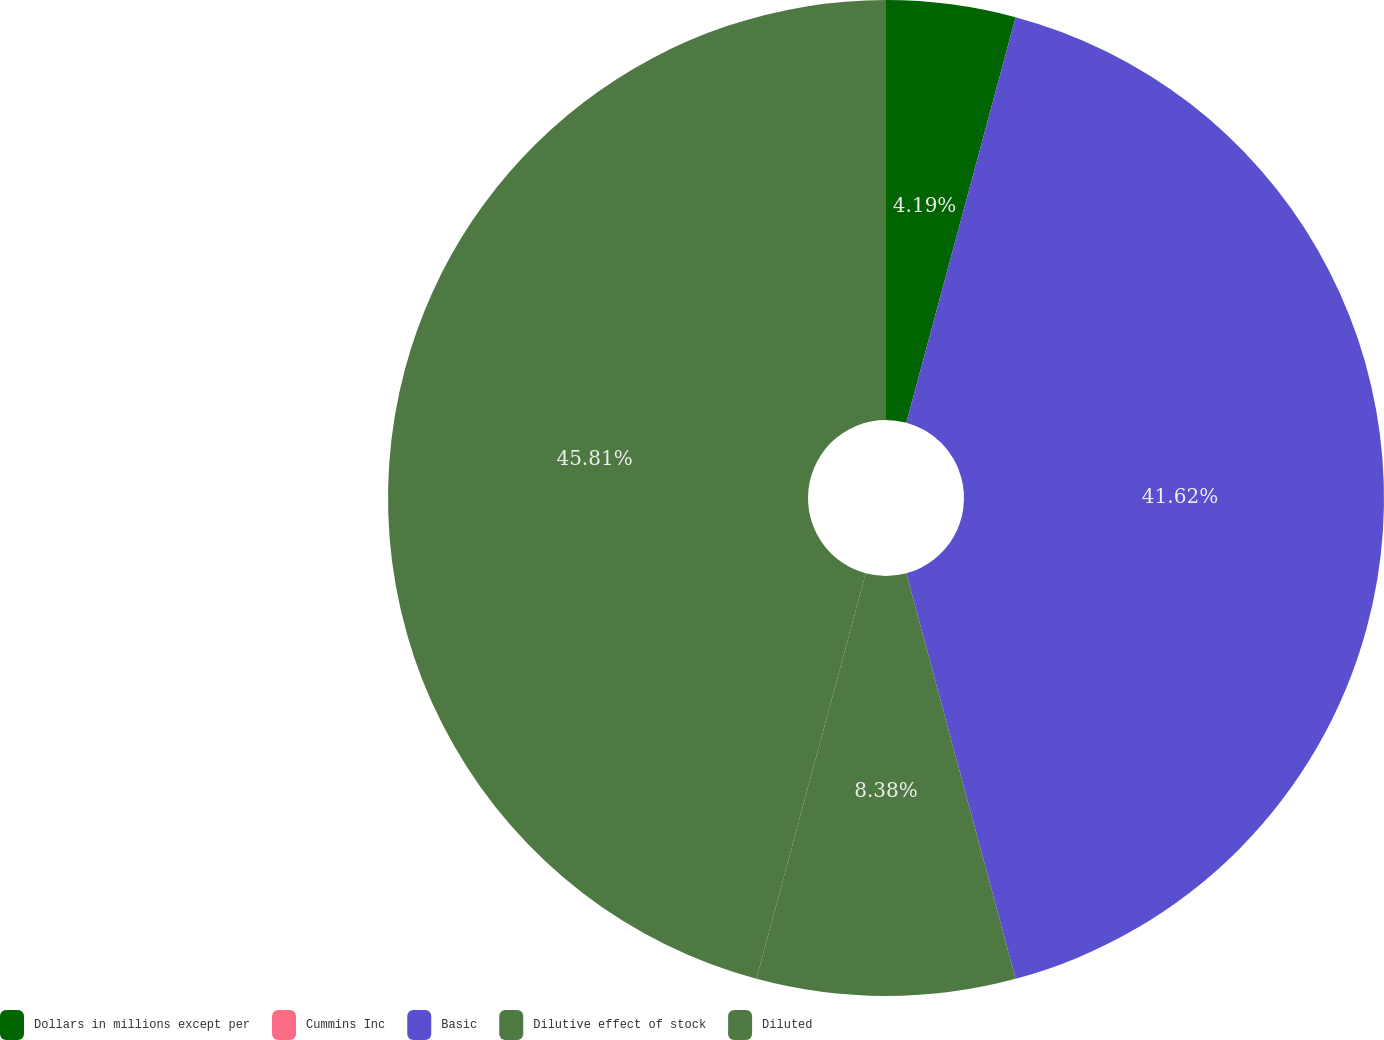Convert chart. <chart><loc_0><loc_0><loc_500><loc_500><pie_chart><fcel>Dollars in millions except per<fcel>Cummins Inc<fcel>Basic<fcel>Dilutive effect of stock<fcel>Diluted<nl><fcel>4.19%<fcel>0.0%<fcel>41.62%<fcel>8.38%<fcel>45.81%<nl></chart> 